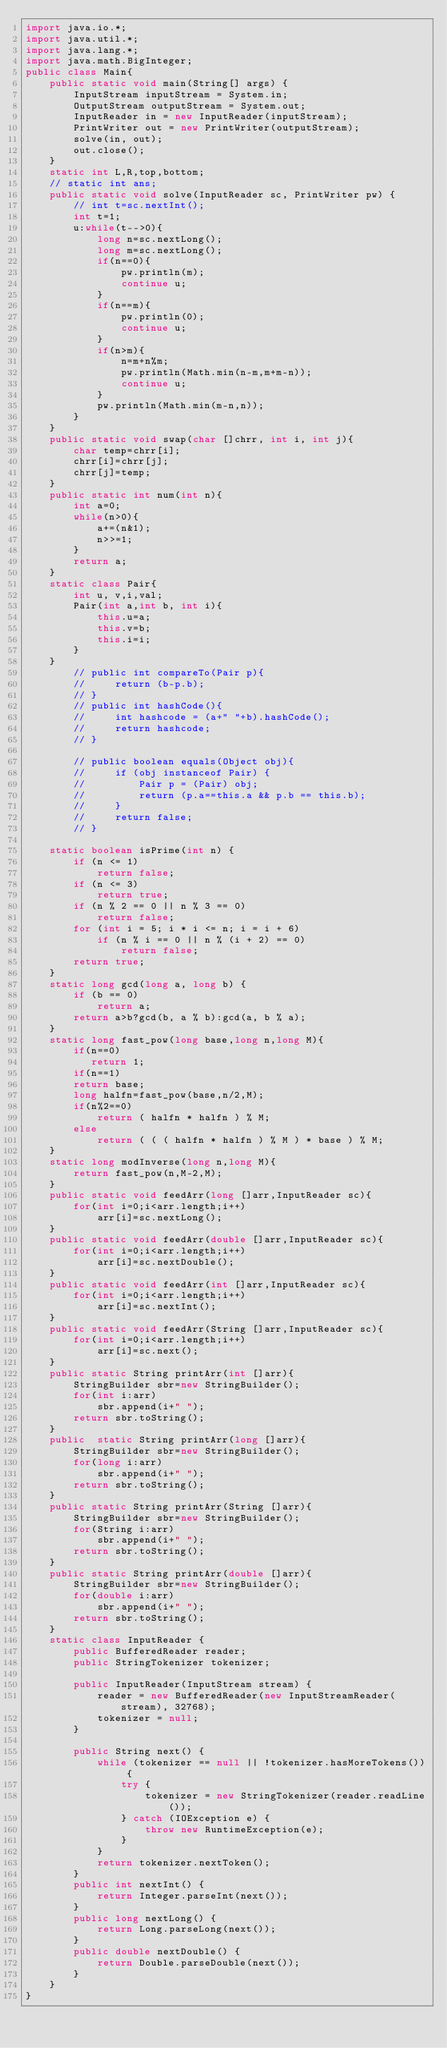<code> <loc_0><loc_0><loc_500><loc_500><_Java_>import java.io.*;
import java.util.*;
import java.lang.*;
import java.math.BigInteger; 
public class Main{
    public static void main(String[] args) {
        InputStream inputStream = System.in;
        OutputStream outputStream = System.out;
        InputReader in = new InputReader(inputStream);
        PrintWriter out = new PrintWriter(outputStream);
        solve(in, out);
        out.close();
    }
    static int L,R,top,bottom;
    // static int ans;
    public static void solve(InputReader sc, PrintWriter pw) {
        // int t=sc.nextInt();
        int t=1;
        u:while(t-->0){
            long n=sc.nextLong();
            long m=sc.nextLong();
            if(n==0){
                pw.println(m);
                continue u;
            }
            if(n==m){
                pw.println(0);
                continue u;
            }
            if(n>m){
                n=m+n%m;
                pw.println(Math.min(n-m,m+m-n));
                continue u;
            }
            pw.println(Math.min(m-n,n));
        }
    }
    public static void swap(char []chrr, int i, int j){
        char temp=chrr[i];
        chrr[i]=chrr[j];
        chrr[j]=temp;
    }
    public static int num(int n){
        int a=0;
        while(n>0){
            a+=(n&1);
            n>>=1;
        }
        return a;
    }
    static class Pair{
        int u, v,i,val;
        Pair(int a,int b, int i){
            this.u=a;
            this.v=b;
            this.i=i;
        }   
    }
        // public int compareTo(Pair p){
        //     return (b-p.b);
        // }
        // public int hashCode(){
        //     int hashcode = (a+" "+b).hashCode();
        //     return hashcode;
        // }
         
        // public boolean equals(Object obj){
        //     if (obj instanceof Pair) {
        //         Pair p = (Pair) obj;
        //         return (p.a==this.a && p.b == this.b);
        //     }
        //     return false;
        // }
 
    static boolean isPrime(int n) { 
        if (n <= 1) 
            return false; 
        if (n <= 3) 
            return true; 
        if (n % 2 == 0 || n % 3 == 0) 
            return false; 
        for (int i = 5; i * i <= n; i = i + 6) 
            if (n % i == 0 || n % (i + 2) == 0) 
                return false; 
        return true; 
    } 
    static long gcd(long a, long b) { 
        if (b == 0) 
            return a; 
        return a>b?gcd(b, a % b):gcd(a, b % a);  
    } 
    static long fast_pow(long base,long n,long M){
        if(n==0)
           return 1;
        if(n==1)
        return base;
        long halfn=fast_pow(base,n/2,M);
        if(n%2==0)
            return ( halfn * halfn ) % M;
        else
            return ( ( ( halfn * halfn ) % M ) * base ) % M;
    }
    static long modInverse(long n,long M){
        return fast_pow(n,M-2,M);
    }
    public static void feedArr(long []arr,InputReader sc){
        for(int i=0;i<arr.length;i++)
            arr[i]=sc.nextLong();
    }
    public static void feedArr(double []arr,InputReader sc){
        for(int i=0;i<arr.length;i++)
            arr[i]=sc.nextDouble();
    }
    public static void feedArr(int []arr,InputReader sc){
        for(int i=0;i<arr.length;i++)
            arr[i]=sc.nextInt();
    }
    public static void feedArr(String []arr,InputReader sc){
        for(int i=0;i<arr.length;i++)
            arr[i]=sc.next();
    }
    public static String printArr(int []arr){
        StringBuilder sbr=new StringBuilder();
        for(int i:arr)
            sbr.append(i+" ");
        return sbr.toString();
    }
    public  static String printArr(long []arr){
        StringBuilder sbr=new StringBuilder();
        for(long i:arr)
            sbr.append(i+" ");
        return sbr.toString();
    }
    public static String printArr(String []arr){
        StringBuilder sbr=new StringBuilder();
        for(String i:arr)
            sbr.append(i+" ");
        return sbr.toString();
    }
    public static String printArr(double []arr){
        StringBuilder sbr=new StringBuilder();
        for(double i:arr)
            sbr.append(i+" ");
        return sbr.toString();
    }
    static class InputReader {
        public BufferedReader reader;
        public StringTokenizer tokenizer;
 
        public InputReader(InputStream stream) {
            reader = new BufferedReader(new InputStreamReader(stream), 32768);
            tokenizer = null;
        }
 
        public String next() {
            while (tokenizer == null || !tokenizer.hasMoreTokens()) {
                try {
                    tokenizer = new StringTokenizer(reader.readLine());
                } catch (IOException e) {
                    throw new RuntimeException(e);
                }
            }
            return tokenizer.nextToken();
        }
        public int nextInt() {
            return Integer.parseInt(next());
        }
        public long nextLong() {
            return Long.parseLong(next());
        }
        public double nextDouble() {
            return Double.parseDouble(next());
        }
    }
}   </code> 